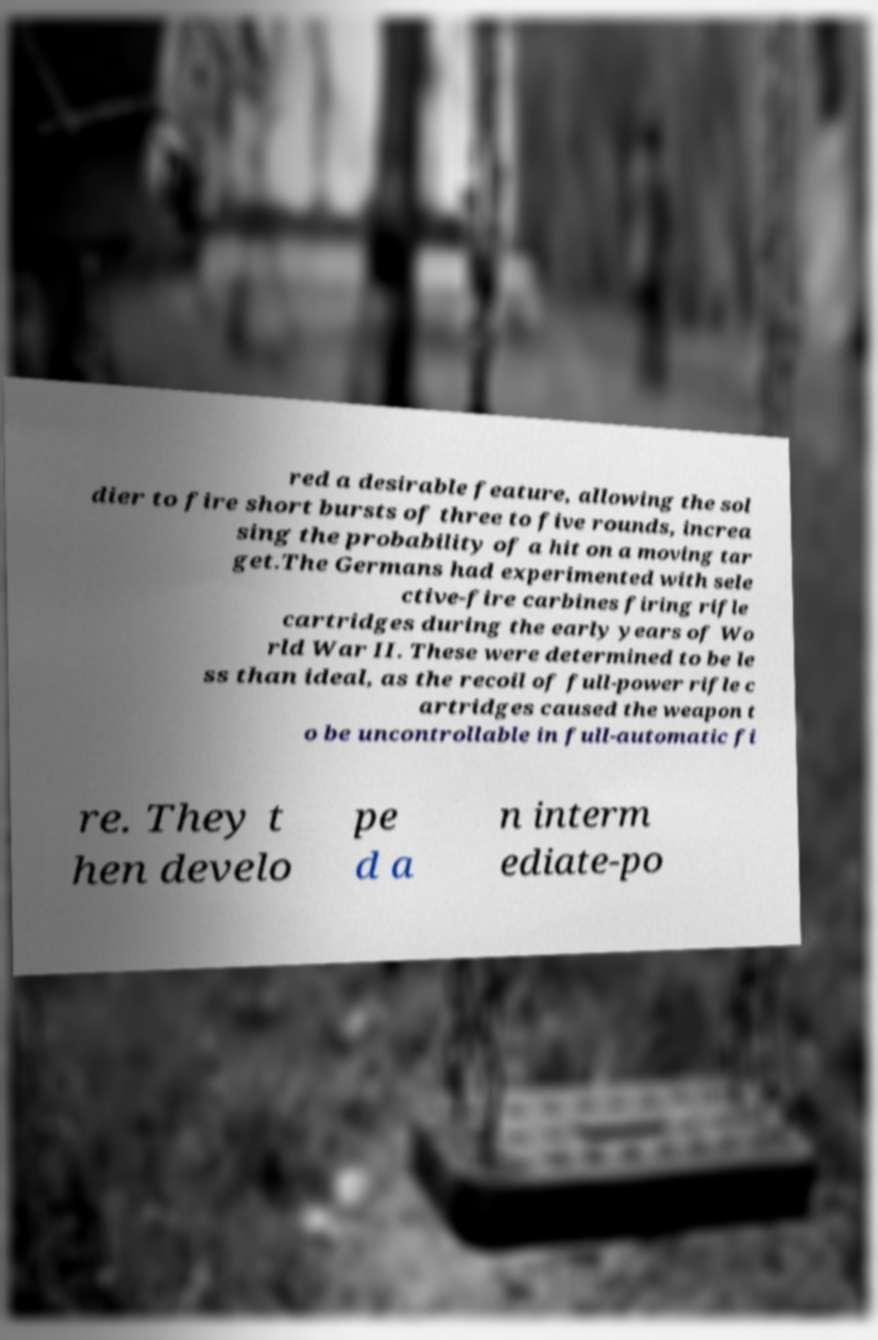Please identify and transcribe the text found in this image. red a desirable feature, allowing the sol dier to fire short bursts of three to five rounds, increa sing the probability of a hit on a moving tar get.The Germans had experimented with sele ctive-fire carbines firing rifle cartridges during the early years of Wo rld War II. These were determined to be le ss than ideal, as the recoil of full-power rifle c artridges caused the weapon t o be uncontrollable in full-automatic fi re. They t hen develo pe d a n interm ediate-po 